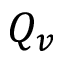Convert formula to latex. <formula><loc_0><loc_0><loc_500><loc_500>Q _ { v }</formula> 